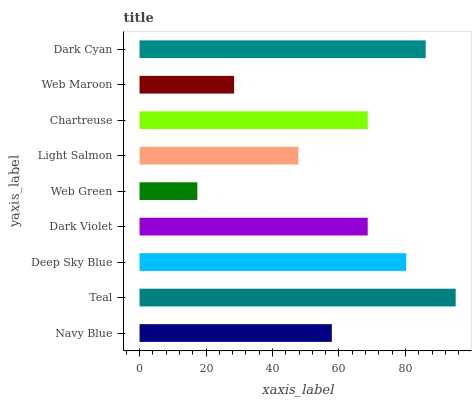Is Web Green the minimum?
Answer yes or no. Yes. Is Teal the maximum?
Answer yes or no. Yes. Is Deep Sky Blue the minimum?
Answer yes or no. No. Is Deep Sky Blue the maximum?
Answer yes or no. No. Is Teal greater than Deep Sky Blue?
Answer yes or no. Yes. Is Deep Sky Blue less than Teal?
Answer yes or no. Yes. Is Deep Sky Blue greater than Teal?
Answer yes or no. No. Is Teal less than Deep Sky Blue?
Answer yes or no. No. Is Dark Violet the high median?
Answer yes or no. Yes. Is Dark Violet the low median?
Answer yes or no. Yes. Is Web Green the high median?
Answer yes or no. No. Is Web Green the low median?
Answer yes or no. No. 